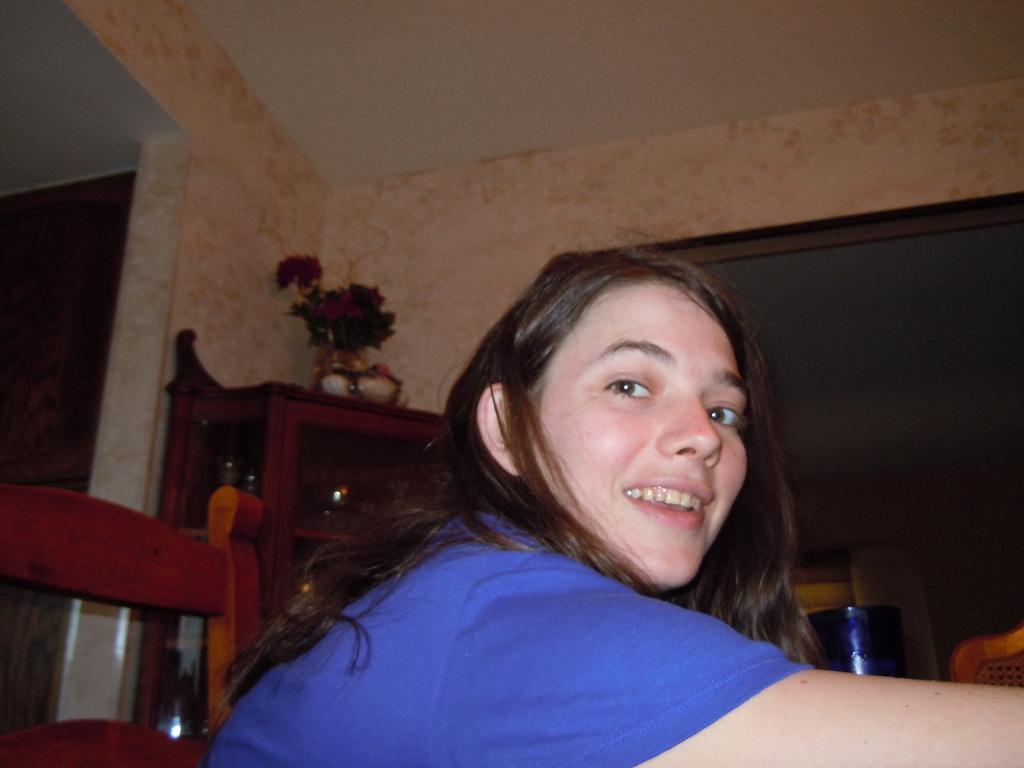How would you summarize this image in a sentence or two? In the given image we can see a women who is looking at a camera and smiling. This is a chair. This is a flower showpiece. 